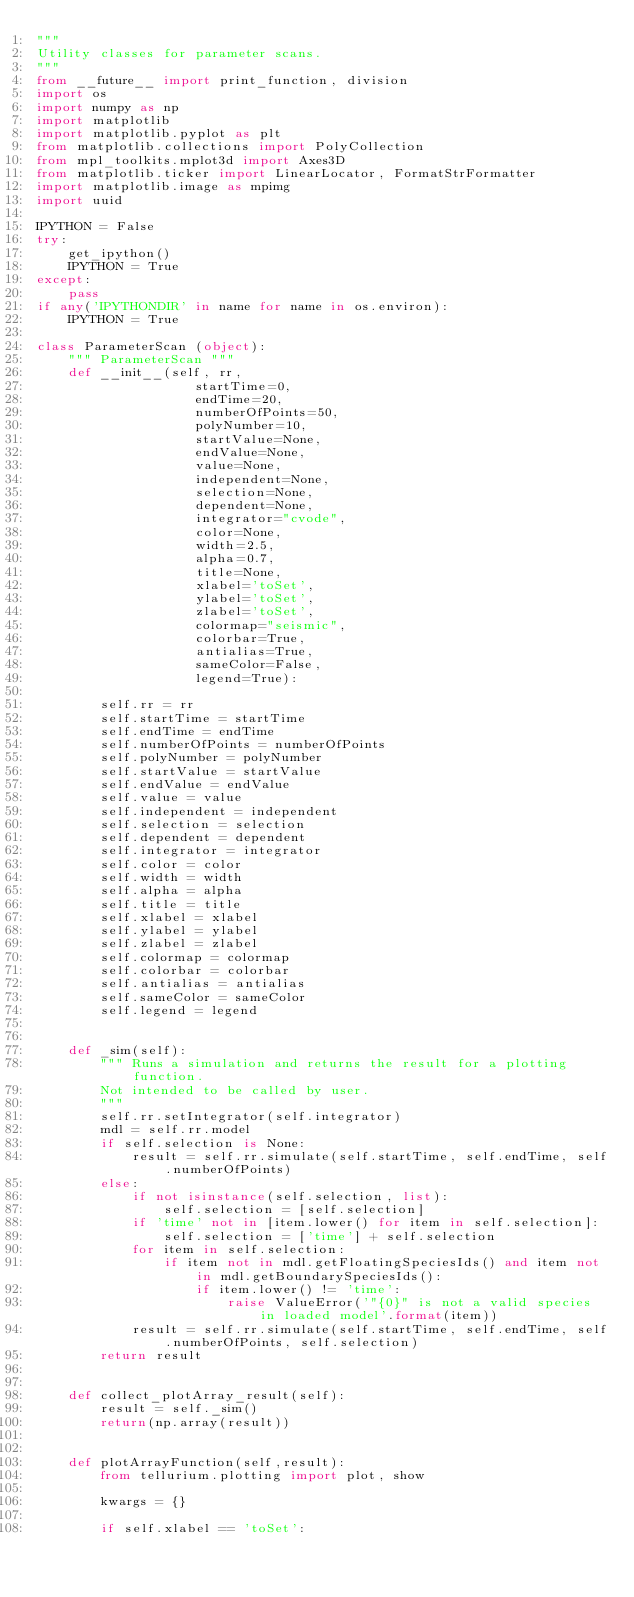Convert code to text. <code><loc_0><loc_0><loc_500><loc_500><_Python_>"""
Utility classes for parameter scans.
"""
from __future__ import print_function, division
import os
import numpy as np
import matplotlib
import matplotlib.pyplot as plt
from matplotlib.collections import PolyCollection
from mpl_toolkits.mplot3d import Axes3D
from matplotlib.ticker import LinearLocator, FormatStrFormatter
import matplotlib.image as mpimg
import uuid

IPYTHON = False
try:
    get_ipython()
    IPYTHON = True
except:
    pass
if any('IPYTHONDIR' in name for name in os.environ):
    IPYTHON = True

class ParameterScan (object):
    """ ParameterScan """
    def __init__(self, rr,
                    startTime=0,
                    endTime=20,
                    numberOfPoints=50,
                    polyNumber=10,
                    startValue=None,
                    endValue=None,
                    value=None,
                    independent=None,
                    selection=None,
                    dependent=None,
                    integrator="cvode",
                    color=None,
                    width=2.5,
                    alpha=0.7,
                    title=None,
                    xlabel='toSet',
                    ylabel='toSet',
                    zlabel='toSet',
                    colormap="seismic",
                    colorbar=True,
                    antialias=True,
                    sameColor=False,
                    legend=True):

        self.rr = rr
        self.startTime = startTime
        self.endTime = endTime
        self.numberOfPoints = numberOfPoints
        self.polyNumber = polyNumber
        self.startValue = startValue
        self.endValue = endValue
        self.value = value
        self.independent = independent
        self.selection = selection
        self.dependent = dependent
        self.integrator = integrator
        self.color = color
        self.width = width
        self.alpha = alpha
        self.title = title
        self.xlabel = xlabel
        self.ylabel = ylabel
        self.zlabel = zlabel
        self.colormap = colormap
        self.colorbar = colorbar
        self.antialias = antialias
        self.sameColor = sameColor
        self.legend = legend


    def _sim(self):
        """ Runs a simulation and returns the result for a plotting function.
        Not intended to be called by user.
        """
        self.rr.setIntegrator(self.integrator)
        mdl = self.rr.model
        if self.selection is None:
            result = self.rr.simulate(self.startTime, self.endTime, self.numberOfPoints)
        else:
            if not isinstance(self.selection, list):
                self.selection = [self.selection]
            if 'time' not in [item.lower() for item in self.selection]:
                self.selection = ['time'] + self.selection
            for item in self.selection:
                if item not in mdl.getFloatingSpeciesIds() and item not in mdl.getBoundarySpeciesIds():
                    if item.lower() != 'time':
                        raise ValueError('"{0}" is not a valid species in loaded model'.format(item))
            result = self.rr.simulate(self.startTime, self.endTime, self.numberOfPoints, self.selection)
        return result


    def collect_plotArray_result(self):
        result = self._sim()
        return(np.array(result))


    def plotArrayFunction(self,result):
        from tellurium.plotting import plot, show

        kwargs = {}

        if self.xlabel == 'toSet':</code> 